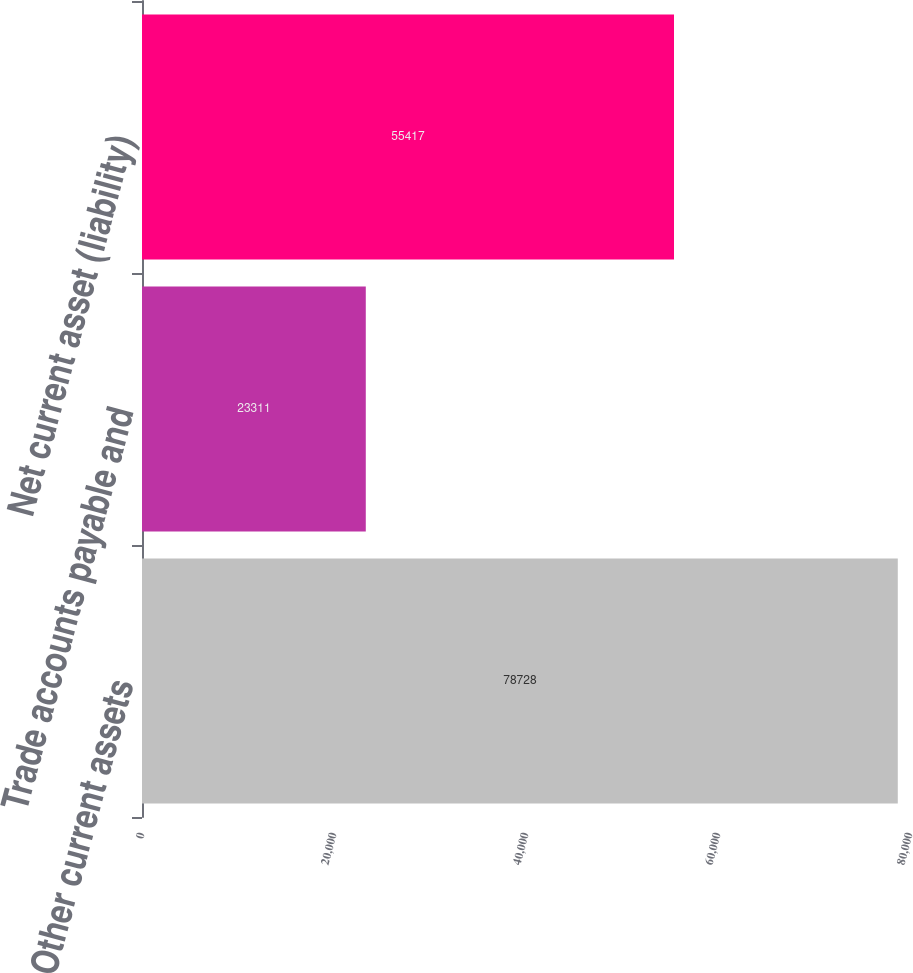Convert chart to OTSL. <chart><loc_0><loc_0><loc_500><loc_500><bar_chart><fcel>Other current assets<fcel>Trade accounts payable and<fcel>Net current asset (liability)<nl><fcel>78728<fcel>23311<fcel>55417<nl></chart> 